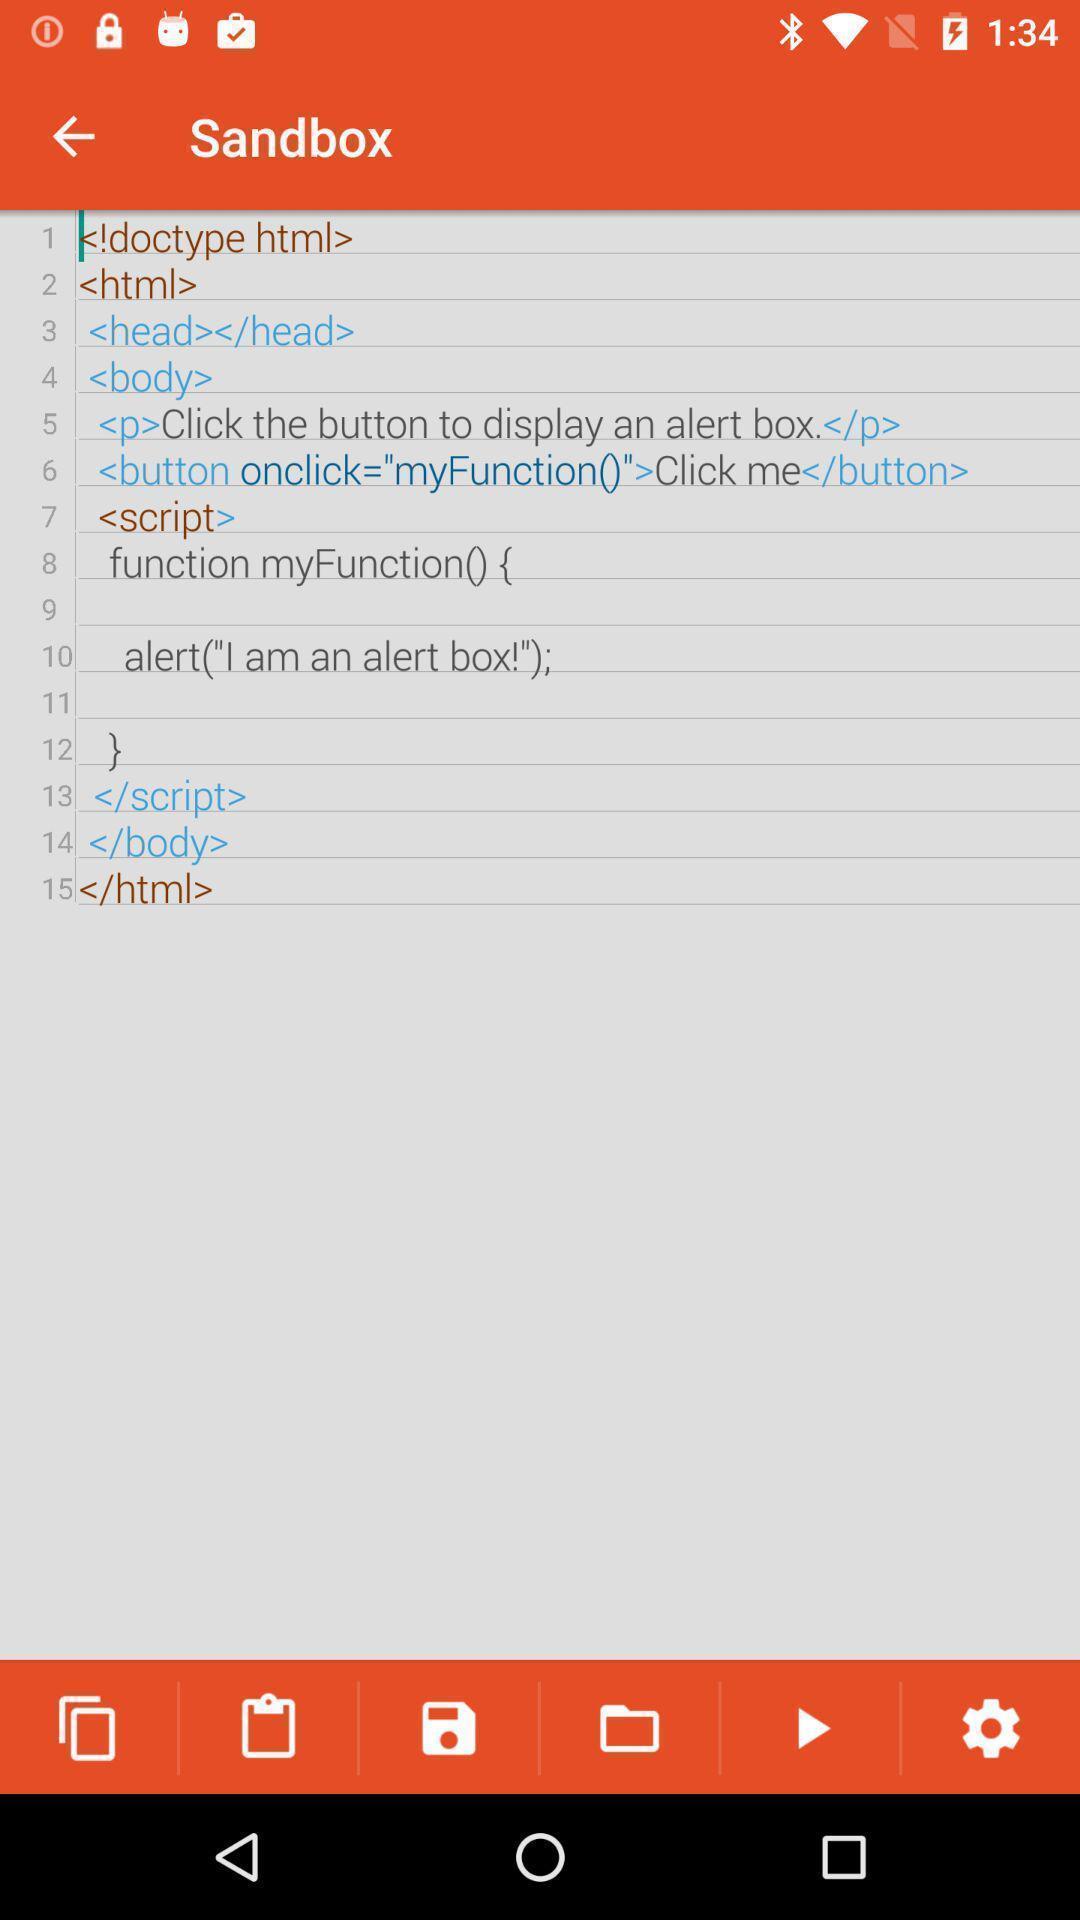Provide a detailed account of this screenshot. Page displaying with a programme. 